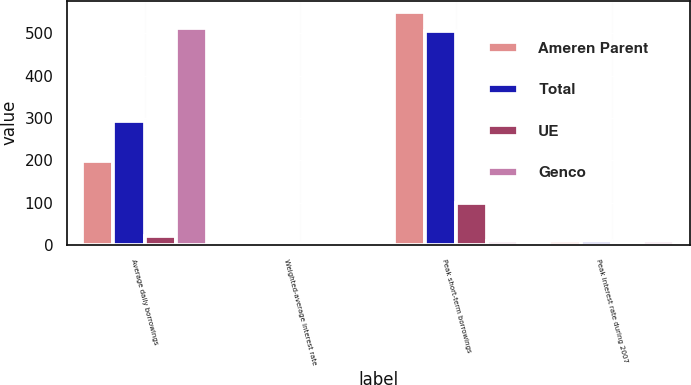Convert chart to OTSL. <chart><loc_0><loc_0><loc_500><loc_500><stacked_bar_chart><ecel><fcel>Average daily borrowings<fcel>Weighted-average interest rate<fcel>Peak short-term borrowings<fcel>Peak interest rate during 2007<nl><fcel>Ameren Parent<fcel>198<fcel>5.75<fcel>550<fcel>8.25<nl><fcel>Total<fcel>292<fcel>5.66<fcel>506<fcel>8.25<nl><fcel>UE<fcel>22<fcel>5.43<fcel>100<fcel>5.76<nl><fcel>Genco<fcel>512<fcel>5.68<fcel>8.25<fcel>8.25<nl></chart> 